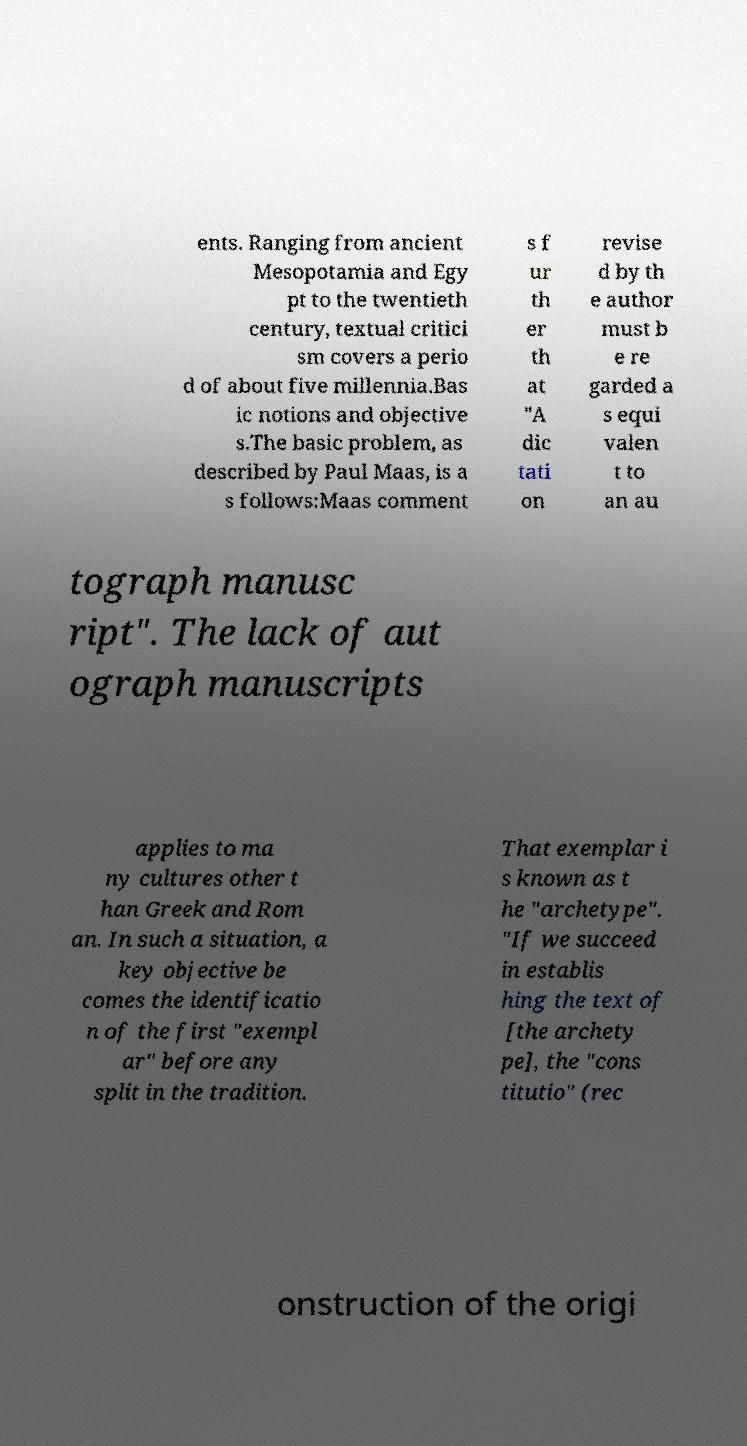Can you accurately transcribe the text from the provided image for me? ents. Ranging from ancient Mesopotamia and Egy pt to the twentieth century, textual critici sm covers a perio d of about five millennia.Bas ic notions and objective s.The basic problem, as described by Paul Maas, is a s follows:Maas comment s f ur th er th at "A dic tati on revise d by th e author must b e re garded a s equi valen t to an au tograph manusc ript". The lack of aut ograph manuscripts applies to ma ny cultures other t han Greek and Rom an. In such a situation, a key objective be comes the identificatio n of the first "exempl ar" before any split in the tradition. That exemplar i s known as t he "archetype". "If we succeed in establis hing the text of [the archety pe], the "cons titutio" (rec onstruction of the origi 